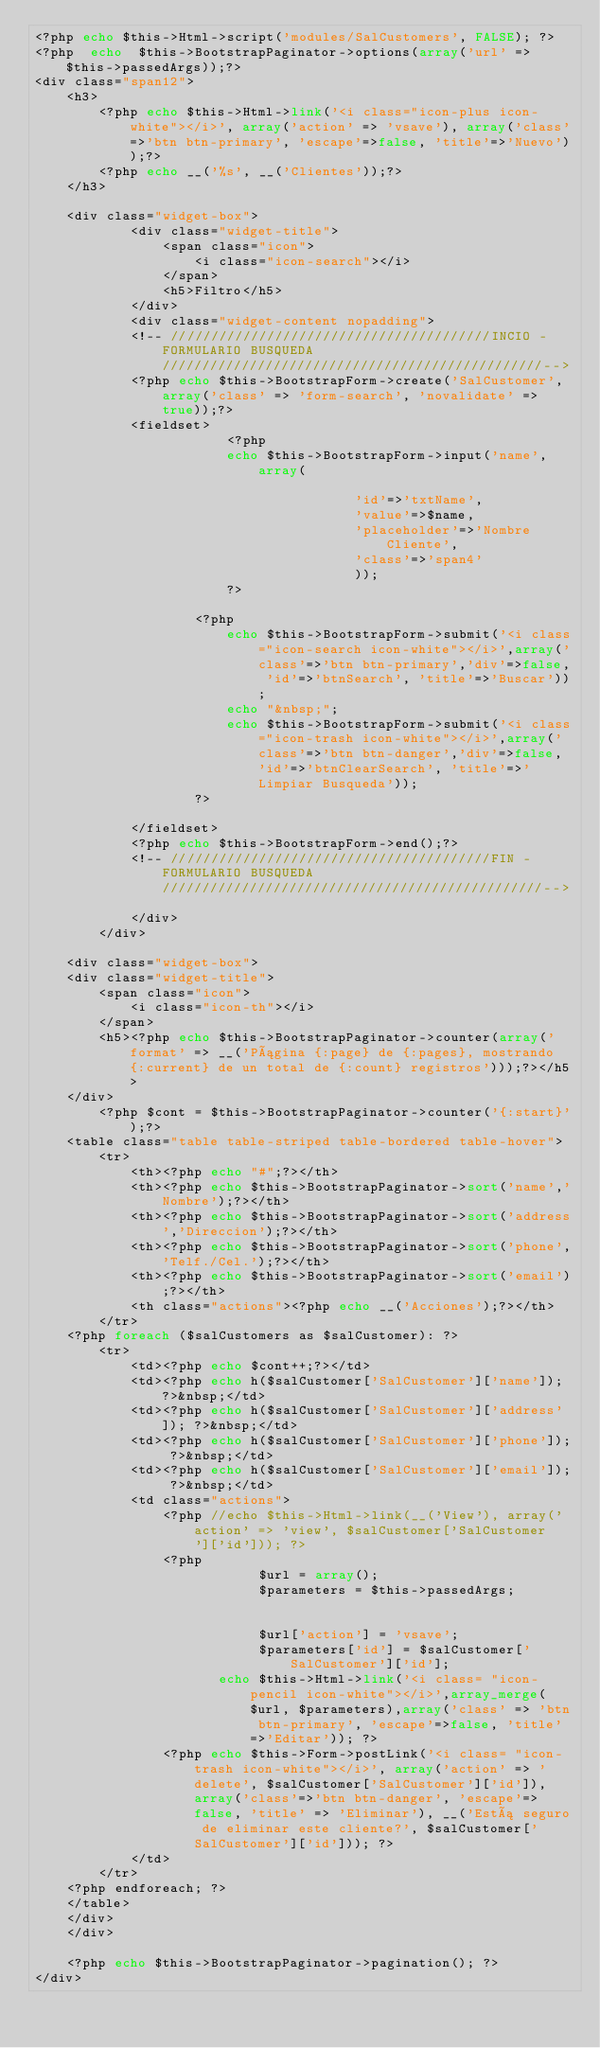Convert code to text. <code><loc_0><loc_0><loc_500><loc_500><_PHP_><?php echo $this->Html->script('modules/SalCustomers', FALSE); ?> 
<?php  echo  $this->BootstrapPaginator->options(array('url' => $this->passedArgs));?>	
<div class="span12">
	<h3>
		<?php echo $this->Html->link('<i class="icon-plus icon-white"></i>', array('action' => 'vsave'), array('class'=>'btn btn-primary', 'escape'=>false, 'title'=>'Nuevo'));?>
		<?php echo __('%s', __('Clientes'));?>
	</h3>
	
	<div class="widget-box">
			<div class="widget-title">
				<span class="icon">
					<i class="icon-search"></i>
				</span>
				<h5>Filtro</h5>
			</div>
			<div class="widget-content nopadding">
			<!-- ////////////////////////////////////////INCIO - FORMULARIO BUSQUEDA////////////////////////////////////////////////-->
			<?php echo $this->BootstrapForm->create('SalCustomer', array('class' => 'form-search', 'novalidate' => true));?>
			<fieldset>
						<?php
						echo $this->BootstrapForm->input('name', array(											
										'id'=>'txtName',
										'value'=>$name,
										'placeholder'=>'Nombre Cliente',
										'class'=>'span4'
										));
						?>				

					<?php
						echo $this->BootstrapForm->submit('<i class="icon-search icon-white"></i>',array('class'=>'btn btn-primary','div'=>false, 'id'=>'btnSearch', 'title'=>'Buscar'));
						echo "&nbsp;";
						echo $this->BootstrapForm->submit('<i class="icon-trash icon-white"></i>',array('class'=>'btn btn-danger','div'=>false, 'id'=>'btnClearSearch', 'title'=>'Limpiar Busqueda'));
					?>

			</fieldset>
			<?php echo $this->BootstrapForm->end();?>
			<!-- ////////////////////////////////////////FIN - FORMULARIO BUSQUEDA////////////////////////////////////////////////-->		
			</div>
		</div>

	<div class="widget-box">
	<div class="widget-title">
		<span class="icon">
			<i class="icon-th"></i>
		</span>
		<h5><?php echo $this->BootstrapPaginator->counter(array('format' => __('Página {:page} de {:pages}, mostrando {:current} de un total de {:count} registros')));?></h5>
	</div>
		<?php $cont = $this->BootstrapPaginator->counter('{:start}');?>
	<table class="table table-striped table-bordered table-hover">
		<tr>
			<th><?php echo "#";?></th>
			<th><?php echo $this->BootstrapPaginator->sort('name','Nombre');?></th>
			<th><?php echo $this->BootstrapPaginator->sort('address','Direccion');?></th>
			<th><?php echo $this->BootstrapPaginator->sort('phone','Telf./Cel.');?></th>
			<th><?php echo $this->BootstrapPaginator->sort('email');?></th>				
			<th class="actions"><?php echo __('Acciones');?></th>
		</tr>
	<?php foreach ($salCustomers as $salCustomer): ?>
		<tr>
			<td><?php echo $cont++;?></td>
			<td><?php echo h($salCustomer['SalCustomer']['name']); ?>&nbsp;</td>
			<td><?php echo h($salCustomer['SalCustomer']['address']); ?>&nbsp;</td>
			<td><?php echo h($salCustomer['SalCustomer']['phone']); ?>&nbsp;</td>
			<td><?php echo h($salCustomer['SalCustomer']['email']); ?>&nbsp;</td>				
			<td class="actions">
				<?php //echo $this->Html->link(__('View'), array('action' => 'view', $salCustomer['SalCustomer']['id'])); ?>
				<?php 
							$url = array();
							$parameters = $this->passedArgs;
						
							
							$url['action'] = 'vsave';
							$parameters['id'] = $salCustomer['SalCustomer']['id'];
					   echo $this->Html->link('<i class= "icon-pencil icon-white"></i>',array_merge($url, $parameters),array('class' => 'btn btn-primary', 'escape'=>false, 'title'=>'Editar')); ?>
				<?php echo $this->Form->postLink('<i class= "icon-trash icon-white"></i>', array('action' => 'delete', $salCustomer['SalCustomer']['id']), array('class'=>'btn btn-danger', 'escape'=>false, 'title' => 'Eliminar'), __('Está seguro de eliminar este cliente?', $salCustomer['SalCustomer']['id'])); ?>
			</td>
		</tr>
	<?php endforeach; ?>
	</table>
	</div>
	</div>

	<?php echo $this->BootstrapPaginator->pagination(); ?>
</div></code> 